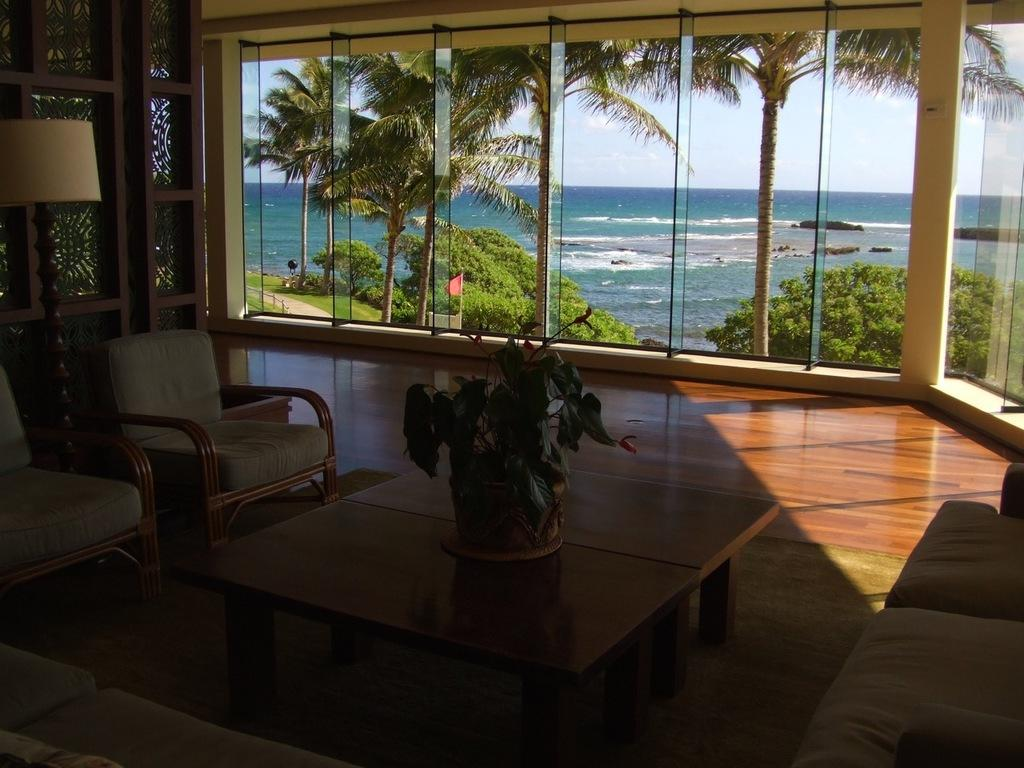What type of furniture is present in the image? There are chairs and a table in the image. What is placed on the table? There is a flower vase on the table. What is located on the floor? There is a lamp on the floor. What type of container is visible in the image? There is a glass in the image. What can be seen in the background of the image? Trees and water are present in the image. How many clocks are hanging on the wall in the image? There are no clocks visible in the image. What type of cushion is placed on the chair in the image? There is no cushion present on the chairs in the image. 